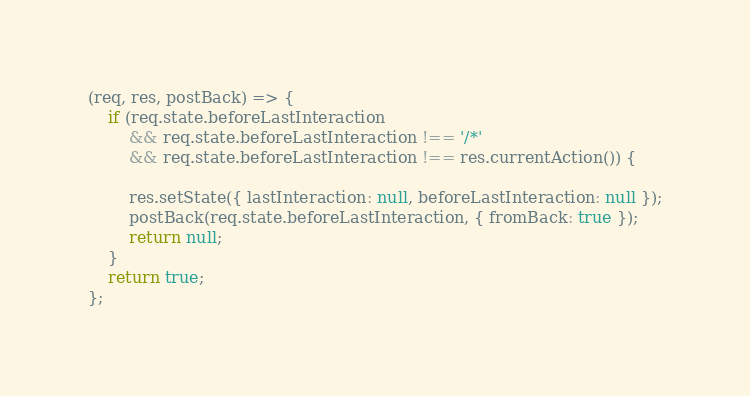<code> <loc_0><loc_0><loc_500><loc_500><_JavaScript_>(req, res, postBack) => {
    if (req.state.beforeLastInteraction
        && req.state.beforeLastInteraction !== '/*'
        && req.state.beforeLastInteraction !== res.currentAction()) {

        res.setState({ lastInteraction: null, beforeLastInteraction: null });
        postBack(req.state.beforeLastInteraction, { fromBack: true });
        return null;
    }
    return true;
};
</code> 